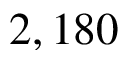Convert formula to latex. <formula><loc_0><loc_0><loc_500><loc_500>2 , 1 8 0</formula> 